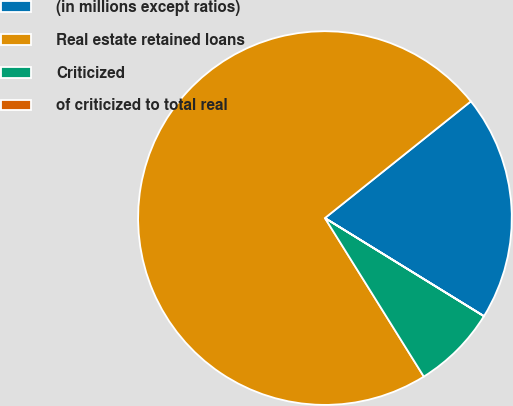Convert chart. <chart><loc_0><loc_0><loc_500><loc_500><pie_chart><fcel>(in millions except ratios)<fcel>Real estate retained loans<fcel>Criticized<fcel>of criticized to total real<nl><fcel>19.53%<fcel>73.14%<fcel>7.32%<fcel>0.01%<nl></chart> 